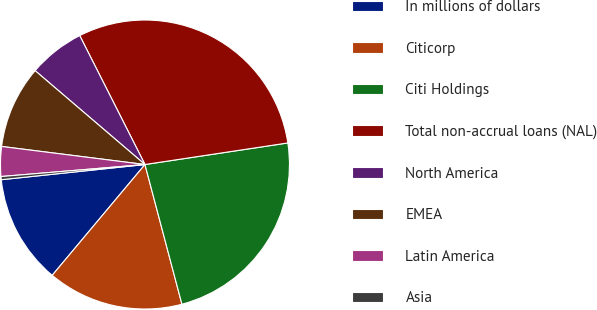Convert chart. <chart><loc_0><loc_0><loc_500><loc_500><pie_chart><fcel>In millions of dollars<fcel>Citicorp<fcel>Citi Holdings<fcel>Total non-accrual loans (NAL)<fcel>North America<fcel>EMEA<fcel>Latin America<fcel>Asia<nl><fcel>12.23%<fcel>15.21%<fcel>23.27%<fcel>30.07%<fcel>6.29%<fcel>9.26%<fcel>3.32%<fcel>0.35%<nl></chart> 